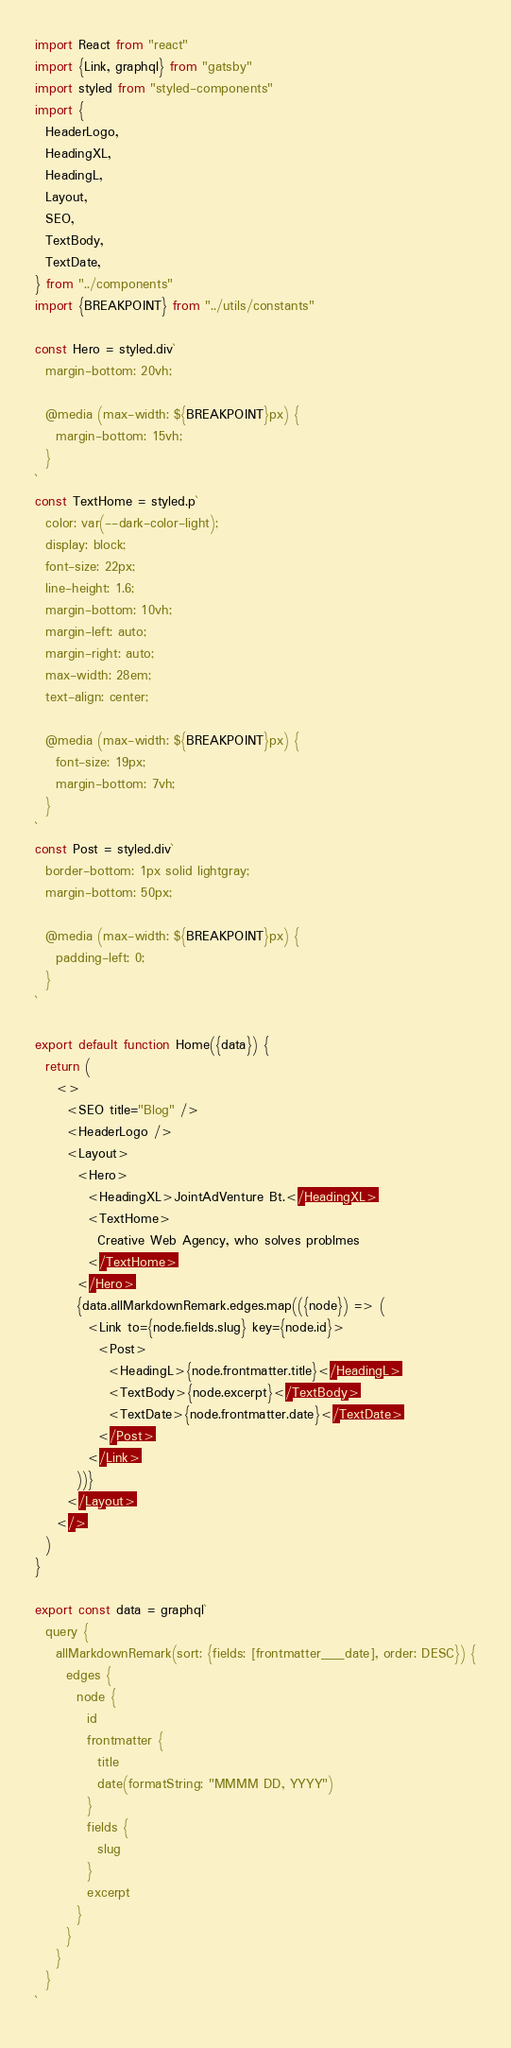Convert code to text. <code><loc_0><loc_0><loc_500><loc_500><_JavaScript_>import React from "react"
import {Link, graphql} from "gatsby"
import styled from "styled-components"
import {
  HeaderLogo,
  HeadingXL,
  HeadingL,
  Layout,
  SEO,
  TextBody,
  TextDate,
} from "../components"
import {BREAKPOINT} from "../utils/constants"

const Hero = styled.div`
  margin-bottom: 20vh;

  @media (max-width: ${BREAKPOINT}px) {
    margin-bottom: 15vh;
  }
`
const TextHome = styled.p`
  color: var(--dark-color-light);
  display: block;
  font-size: 22px;
  line-height: 1.6;
  margin-bottom: 10vh;
  margin-left: auto;
  margin-right: auto;
  max-width: 28em;
  text-align: center;

  @media (max-width: ${BREAKPOINT}px) {
    font-size: 19px;
    margin-bottom: 7vh;
  }
`
const Post = styled.div`
  border-bottom: 1px solid lightgray;
  margin-bottom: 50px;

  @media (max-width: ${BREAKPOINT}px) {
    padding-left: 0;
  }
`

export default function Home({data}) {
  return (
    <>
      <SEO title="Blog" />
      <HeaderLogo />
      <Layout>
        <Hero>
          <HeadingXL>JointAdVenture Bt.</HeadingXL>
          <TextHome>
            Creative Web Agency, who solves problmes
          </TextHome>
        </Hero>
        {data.allMarkdownRemark.edges.map(({node}) => (
          <Link to={node.fields.slug} key={node.id}>
            <Post>
              <HeadingL>{node.frontmatter.title}</HeadingL>
              <TextBody>{node.excerpt}</TextBody>
              <TextDate>{node.frontmatter.date}</TextDate>
            </Post>
          </Link>
        ))}
      </Layout>
    </>
  )
}

export const data = graphql`
  query {
    allMarkdownRemark(sort: {fields: [frontmatter___date], order: DESC}) {
      edges {
        node {
          id
          frontmatter {
            title
            date(formatString: "MMMM DD, YYYY")
          }
          fields {
            slug
          }
          excerpt
        }
      }
    }
  }
`
</code> 